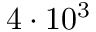Convert formula to latex. <formula><loc_0><loc_0><loc_500><loc_500>4 \cdot 1 0 ^ { 3 }</formula> 